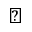<formula> <loc_0><loc_0><loc_500><loc_500>\clubsuit</formula> 